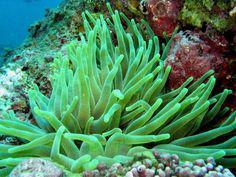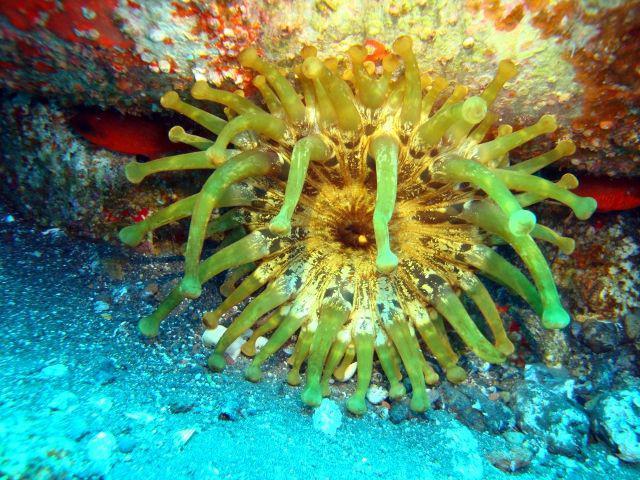The first image is the image on the left, the second image is the image on the right. Assess this claim about the two images: "An image shows multipe individual orange anemone and no other color anemone.". Correct or not? Answer yes or no. No. The first image is the image on the left, the second image is the image on the right. Given the left and right images, does the statement "there are at least six red anemones in one of the images" hold true? Answer yes or no. No. 